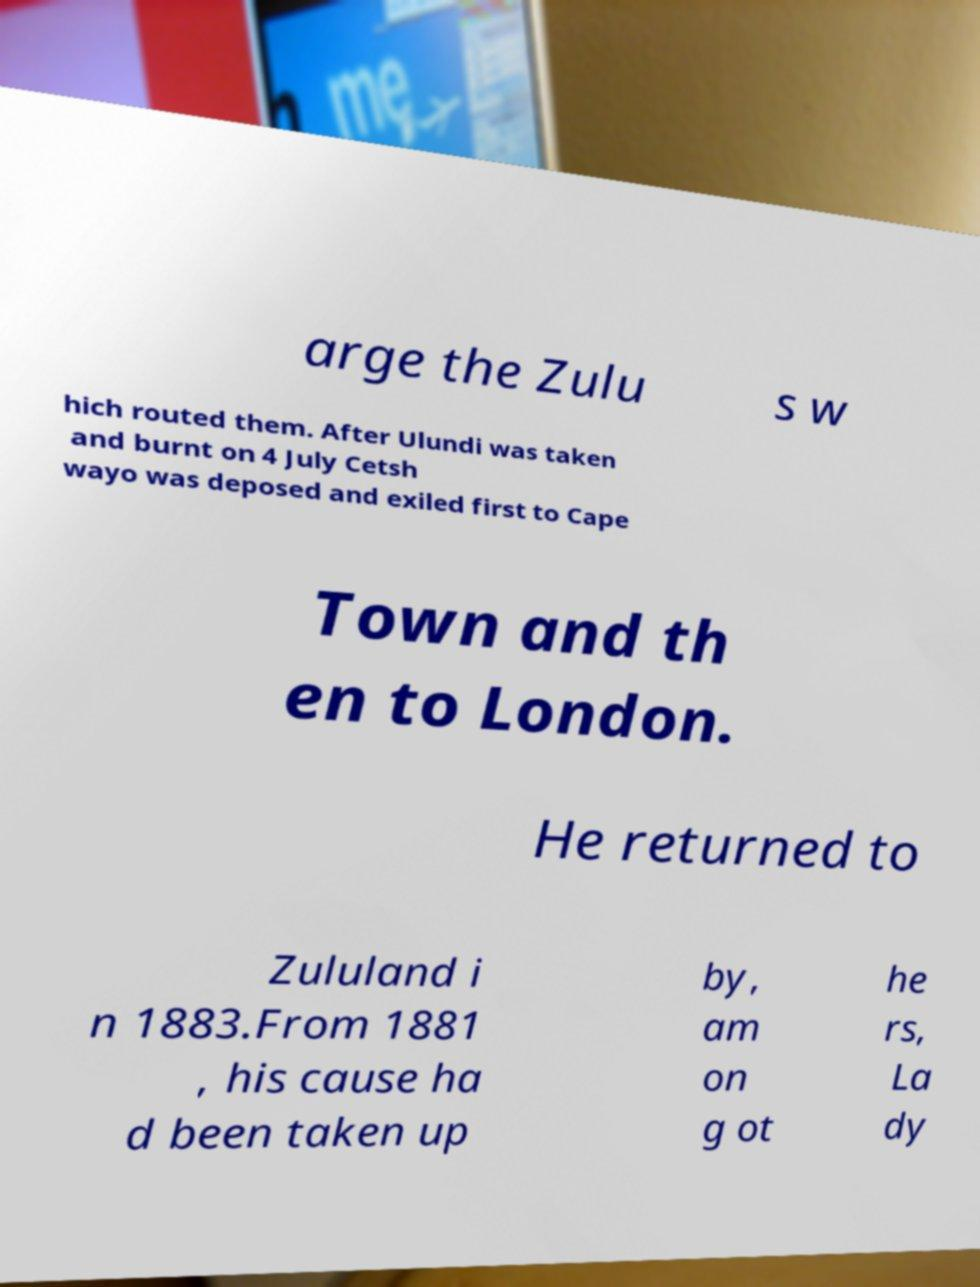Can you accurately transcribe the text from the provided image for me? arge the Zulu s w hich routed them. After Ulundi was taken and burnt on 4 July Cetsh wayo was deposed and exiled first to Cape Town and th en to London. He returned to Zululand i n 1883.From 1881 , his cause ha d been taken up by, am on g ot he rs, La dy 